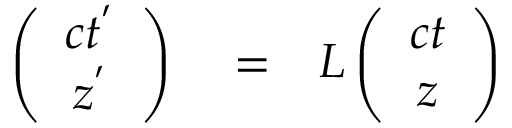Convert formula to latex. <formula><loc_0><loc_0><loc_500><loc_500>\begin{array} { r l r } { \left ( \begin{array} { c c } { c t ^ { ^ { \prime } } } \\ { z ^ { ^ { \prime } } } \end{array} \right ) } & = } & { L \left ( \begin{array} { c c } { c t } \\ { z } \end{array} \right ) } \end{array}</formula> 